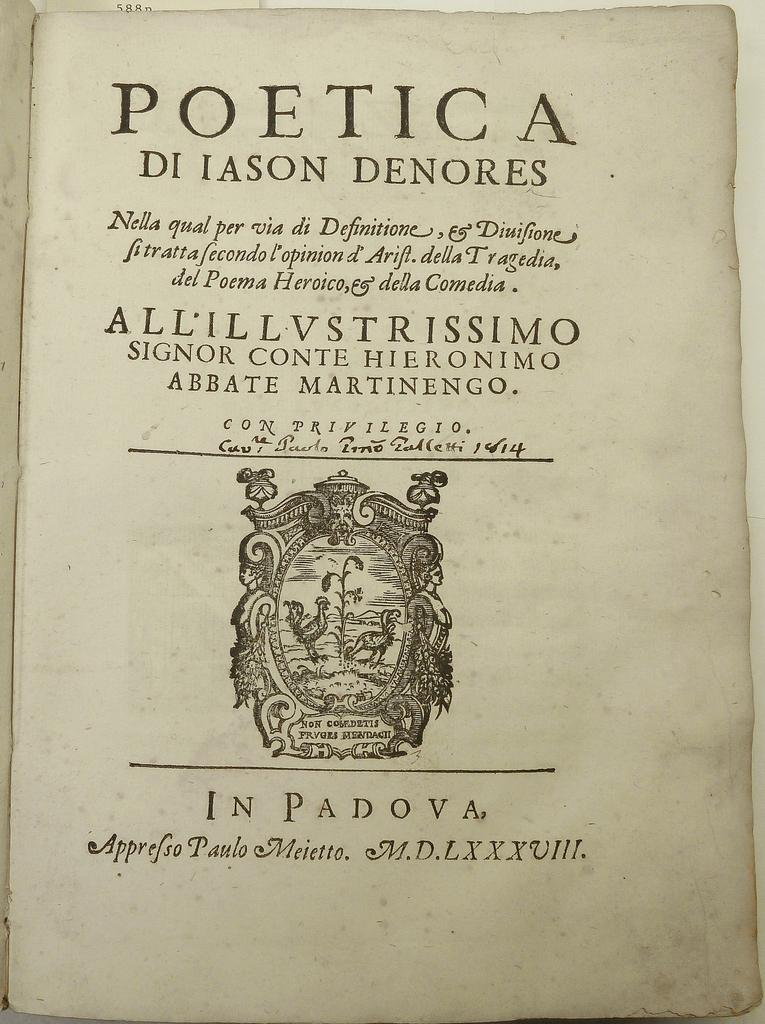<image>
Give a short and clear explanation of the subsequent image. An aged page of a book has the title Poetica. 